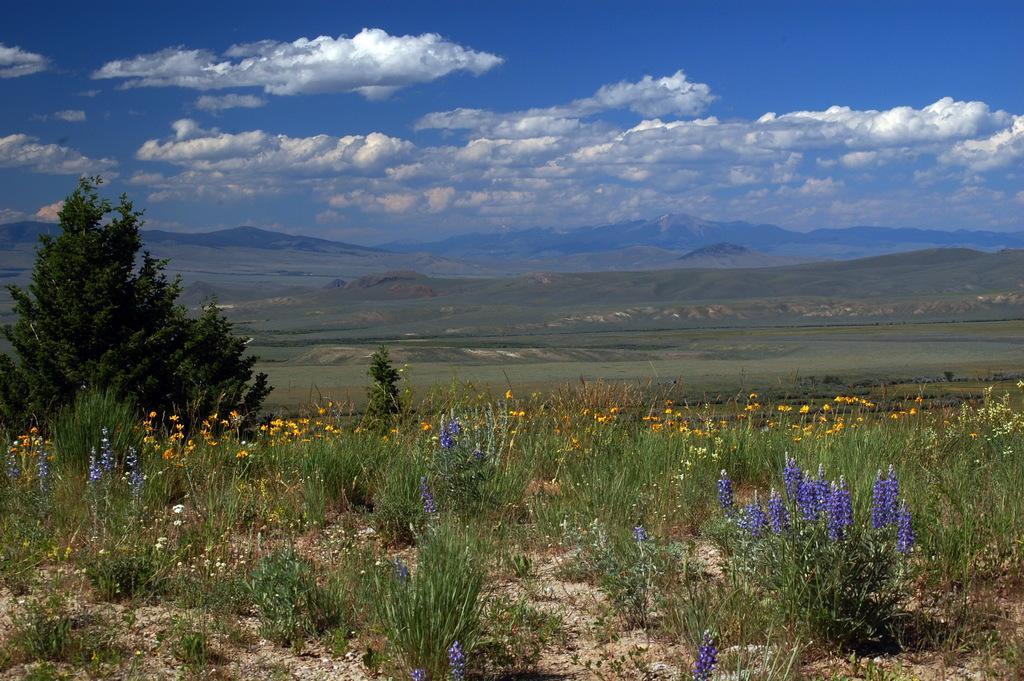Can you describe this image briefly? In this image there are few plants having flowers and trees are on the land. Behind there is grassland and few hills. Top of image there is sky with some clouds. 